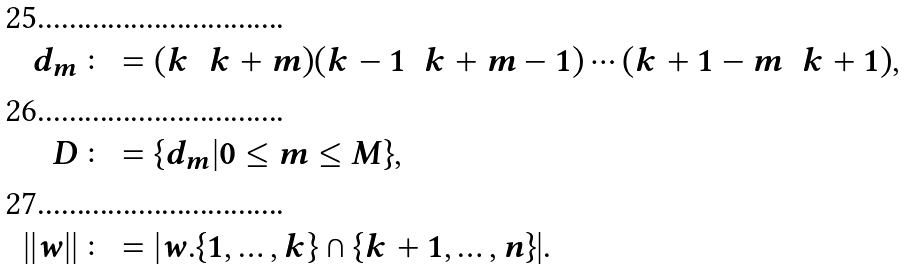Convert formula to latex. <formula><loc_0><loc_0><loc_500><loc_500>d _ { m } & \colon = ( k \ \ k + m ) ( k - 1 \ \ k + m - 1 ) \cdots ( k + 1 - m \ \ k + 1 ) , \\ D & \colon = \{ d _ { m } | 0 \leq m \leq M \} , \\ | | w | | & \colon = | w . \{ 1 , \dots , k \} \cap \{ k + 1 , \dots , n \} | .</formula> 